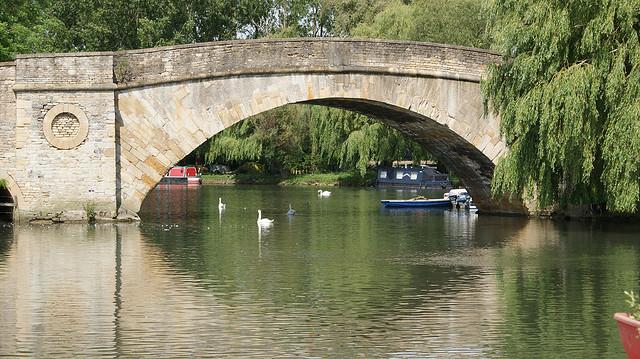Is the water calm?
Quick response, please. Yes. What animals do you see in the river?
Be succinct. Ducks. Is the bridge old?
Concise answer only. Yes. 